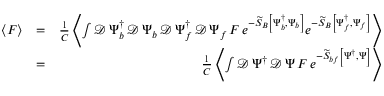<formula> <loc_0><loc_0><loc_500><loc_500>\begin{array} { r l r } { \left \langle F \right \rangle } & { = } & { \frac { 1 } { C } \left \langle \int \mathcal { D } \, \Psi _ { b } ^ { \dagger } \, \mathcal { D } \, \Psi _ { b } \, \mathcal { D } \, \Psi _ { f } ^ { \dagger } \, \mathcal { D } \, \Psi _ { f } \, F \, e ^ { - \widetilde { S } _ { B } \left [ \Psi _ { b } ^ { \dagger } , \Psi _ { b } \right ] } e ^ { - \widetilde { S } _ { B } \left [ \Psi _ { f } ^ { \dagger } , \Psi _ { f } \right ] } \right \rangle } \\ & { = } & { \frac { 1 } { C } \left \langle \int \mathcal { D } \, \Psi ^ { \dagger } \, \mathcal { D } \, \Psi \, F \, e ^ { - \widetilde { S } _ { b f } \left [ \Psi ^ { \dagger } , \Psi \right ] } \right \rangle } \end{array}</formula> 